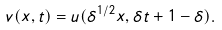<formula> <loc_0><loc_0><loc_500><loc_500>v ( x , t ) = u ( \delta ^ { 1 / 2 } x , \delta t + 1 - \delta ) .</formula> 